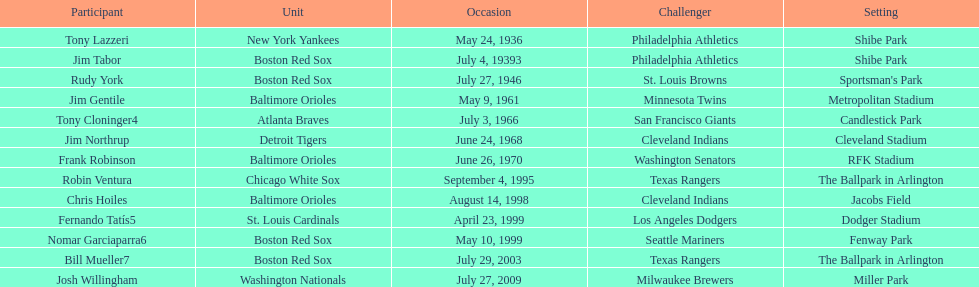Write the full table. {'header': ['Participant', 'Unit', 'Occasion', 'Challenger', 'Setting'], 'rows': [['Tony Lazzeri', 'New York Yankees', 'May 24, 1936', 'Philadelphia Athletics', 'Shibe Park'], ['Jim Tabor', 'Boston Red Sox', 'July 4, 19393', 'Philadelphia Athletics', 'Shibe Park'], ['Rudy York', 'Boston Red Sox', 'July 27, 1946', 'St. Louis Browns', "Sportsman's Park"], ['Jim Gentile', 'Baltimore Orioles', 'May 9, 1961', 'Minnesota Twins', 'Metropolitan Stadium'], ['Tony Cloninger4', 'Atlanta Braves', 'July 3, 1966', 'San Francisco Giants', 'Candlestick Park'], ['Jim Northrup', 'Detroit Tigers', 'June 24, 1968', 'Cleveland Indians', 'Cleveland Stadium'], ['Frank Robinson', 'Baltimore Orioles', 'June 26, 1970', 'Washington Senators', 'RFK Stadium'], ['Robin Ventura', 'Chicago White Sox', 'September 4, 1995', 'Texas Rangers', 'The Ballpark in Arlington'], ['Chris Hoiles', 'Baltimore Orioles', 'August 14, 1998', 'Cleveland Indians', 'Jacobs Field'], ['Fernando Tatís5', 'St. Louis Cardinals', 'April 23, 1999', 'Los Angeles Dodgers', 'Dodger Stadium'], ['Nomar Garciaparra6', 'Boston Red Sox', 'May 10, 1999', 'Seattle Mariners', 'Fenway Park'], ['Bill Mueller7', 'Boston Red Sox', 'July 29, 2003', 'Texas Rangers', 'The Ballpark in Arlington'], ['Josh Willingham', 'Washington Nationals', 'July 27, 2009', 'Milwaukee Brewers', 'Miller Park']]} On what date did the detroit tigers play the cleveland indians? June 24, 1968. 